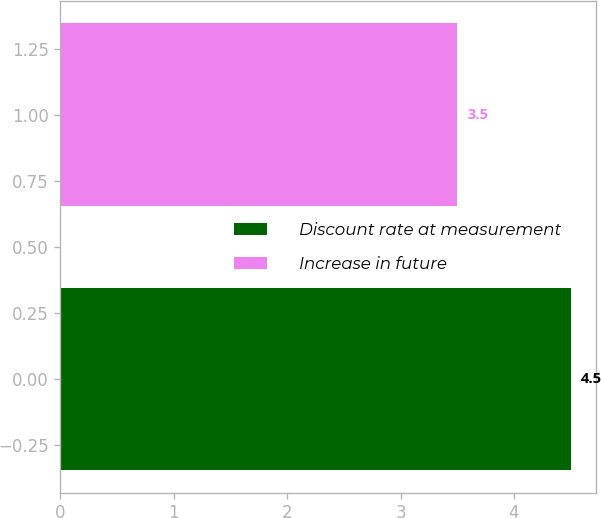Convert chart to OTSL. <chart><loc_0><loc_0><loc_500><loc_500><bar_chart><fcel>Discount rate at measurement<fcel>Increase in future<nl><fcel>4.5<fcel>3.5<nl></chart> 